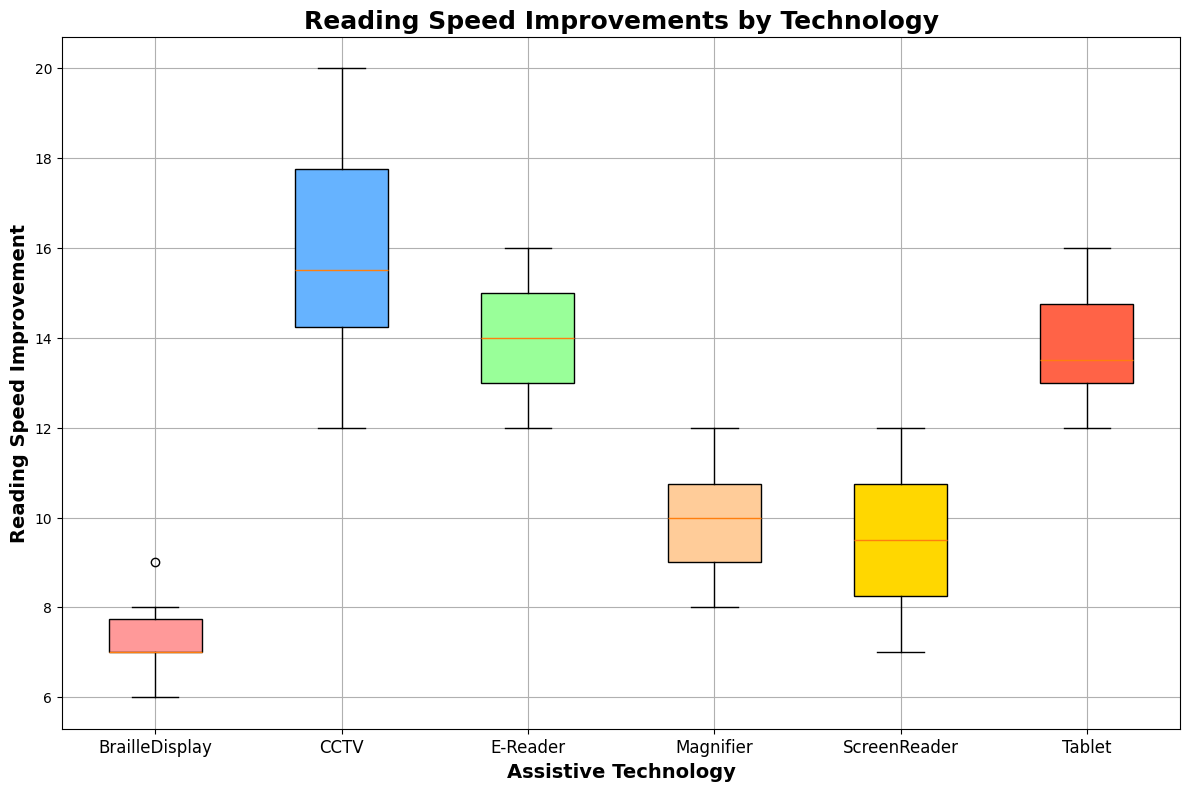Which assistive technology shows the highest median reading speed improvement? The box plot shows the median as the middle line in each box. From the figure, the technology 'CCTV' has the highest median since its middle line is higher than those of the other technologies.
Answer: CCTV What is the range of reading speed improvements for E-Reader technology? To find the range, identify the lowest and highest values in the box plot for 'E-Reader'. The lowest value (whisker bottom) is 12, and the highest value (whisker top) is 16. The range is 16 - 12 = 4.
Answer: 4 Which assistive technology has the most consistent (least variable) reading speed improvement? Consistency can be judged by the height of the box and the distance between the whiskers. The 'BrailleDisplay' has the smallest height in the box plot and least distance between whiskers, indicating the least variability.
Answer: BrailleDisplay What is the interquartile range (IQR) for the ScreenReader technology? The IQR is the difference between the third quartile (top of the box) and the first quartile (bottom of the box). For 'ScreenReader', the IQR is 11 - 8 = 3.
Answer: 3 Compare the median reading speed improvement of Tablet and Magnifier. Which has a higher median? The median is indicated by the line in the middle of each box. The 'Tablet' median line is at 13.5 while the 'Magnifier' median is at 10. Therefore, 'Tablet' has a higher median.
Answer: Tablet Which technology shows the highest maximum reading speed improvement? The maximum value is indicated by the top whisker for each technology. 'CCTV' has the top whisker reaching 20, which is the highest maximum value shown in the plot.
Answer: CCTV Do any technologies have outliers in their reading speed improvements? Outliers are typically shown as individual points outside the whiskers. Given the information, there are no individual points outside the whiskers in this plot, so there are no outliers.
Answer: No Is there any technology where the median value is identical to the maximum value in the box plot? Examine each box plot's median line (middle of the box) and the top whisker. None of the median lines reach the top whisker, meaning no technology has its median value identical to the maximum value.
Answer: No Which assistive technology shows the greatest spread in its reading speed improvements? The spread is indicated by the distance between the bottom and top whiskers. 'CCTV' has the greatest spread with a distance between whiskers from 12 to 20, resulting in a spread of 8.
Answer: CCTV 